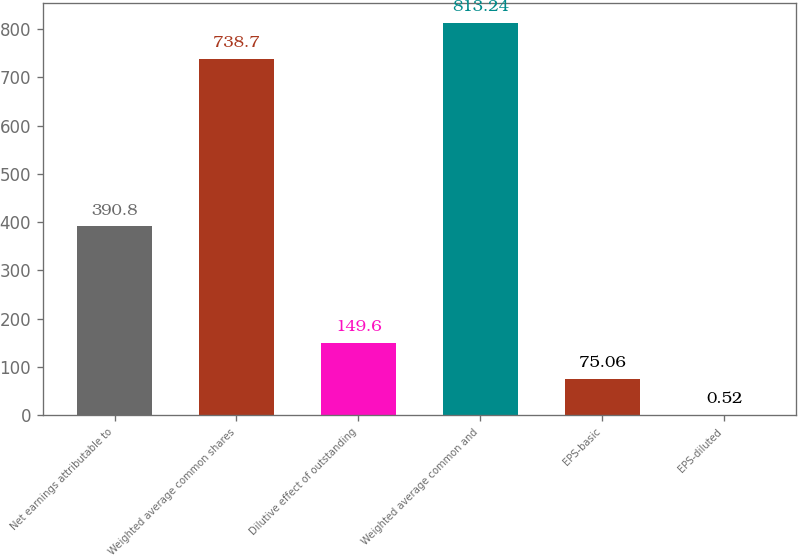Convert chart. <chart><loc_0><loc_0><loc_500><loc_500><bar_chart><fcel>Net earnings attributable to<fcel>Weighted average common shares<fcel>Dilutive effect of outstanding<fcel>Weighted average common and<fcel>EPS-basic<fcel>EPS-diluted<nl><fcel>390.8<fcel>738.7<fcel>149.6<fcel>813.24<fcel>75.06<fcel>0.52<nl></chart> 